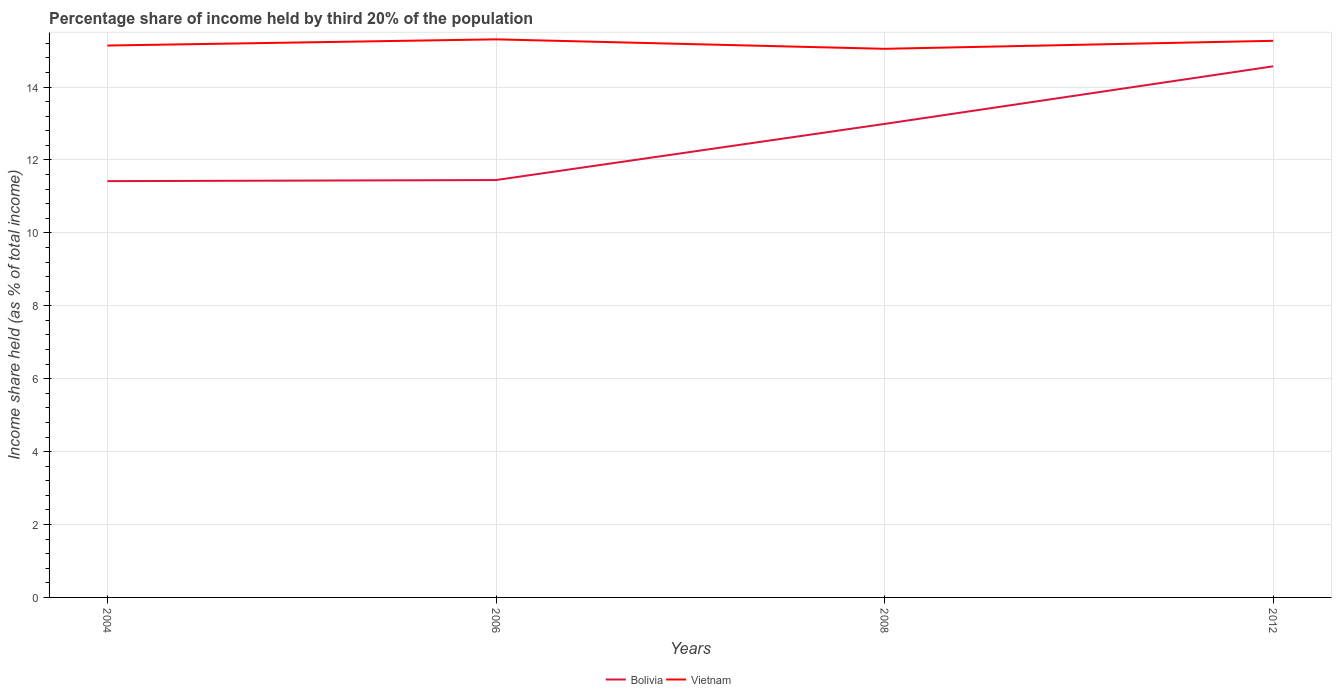Across all years, what is the maximum share of income held by third 20% of the population in Bolivia?
Give a very brief answer. 11.42. In which year was the share of income held by third 20% of the population in Vietnam maximum?
Keep it short and to the point. 2008. What is the total share of income held by third 20% of the population in Bolivia in the graph?
Your response must be concise. -0.03. What is the difference between the highest and the second highest share of income held by third 20% of the population in Vietnam?
Your response must be concise. 0.26. Is the share of income held by third 20% of the population in Vietnam strictly greater than the share of income held by third 20% of the population in Bolivia over the years?
Your answer should be compact. No. How many lines are there?
Offer a terse response. 2. Are the values on the major ticks of Y-axis written in scientific E-notation?
Provide a succinct answer. No. Does the graph contain any zero values?
Keep it short and to the point. No. Does the graph contain grids?
Offer a terse response. Yes. Where does the legend appear in the graph?
Provide a succinct answer. Bottom center. How are the legend labels stacked?
Offer a terse response. Horizontal. What is the title of the graph?
Your answer should be very brief. Percentage share of income held by third 20% of the population. What is the label or title of the X-axis?
Provide a succinct answer. Years. What is the label or title of the Y-axis?
Offer a very short reply. Income share held (as % of total income). What is the Income share held (as % of total income) of Bolivia in 2004?
Provide a succinct answer. 11.42. What is the Income share held (as % of total income) of Vietnam in 2004?
Your answer should be very brief. 15.14. What is the Income share held (as % of total income) in Bolivia in 2006?
Make the answer very short. 11.45. What is the Income share held (as % of total income) of Vietnam in 2006?
Ensure brevity in your answer.  15.31. What is the Income share held (as % of total income) in Bolivia in 2008?
Make the answer very short. 12.99. What is the Income share held (as % of total income) of Vietnam in 2008?
Provide a short and direct response. 15.05. What is the Income share held (as % of total income) of Bolivia in 2012?
Provide a succinct answer. 14.57. What is the Income share held (as % of total income) of Vietnam in 2012?
Provide a short and direct response. 15.27. Across all years, what is the maximum Income share held (as % of total income) in Bolivia?
Provide a succinct answer. 14.57. Across all years, what is the maximum Income share held (as % of total income) in Vietnam?
Make the answer very short. 15.31. Across all years, what is the minimum Income share held (as % of total income) of Bolivia?
Your answer should be compact. 11.42. Across all years, what is the minimum Income share held (as % of total income) of Vietnam?
Ensure brevity in your answer.  15.05. What is the total Income share held (as % of total income) in Bolivia in the graph?
Your response must be concise. 50.43. What is the total Income share held (as % of total income) of Vietnam in the graph?
Your response must be concise. 60.77. What is the difference between the Income share held (as % of total income) of Bolivia in 2004 and that in 2006?
Your answer should be very brief. -0.03. What is the difference between the Income share held (as % of total income) in Vietnam in 2004 and that in 2006?
Make the answer very short. -0.17. What is the difference between the Income share held (as % of total income) in Bolivia in 2004 and that in 2008?
Offer a very short reply. -1.57. What is the difference between the Income share held (as % of total income) of Vietnam in 2004 and that in 2008?
Give a very brief answer. 0.09. What is the difference between the Income share held (as % of total income) of Bolivia in 2004 and that in 2012?
Your answer should be very brief. -3.15. What is the difference between the Income share held (as % of total income) of Vietnam in 2004 and that in 2012?
Provide a succinct answer. -0.13. What is the difference between the Income share held (as % of total income) of Bolivia in 2006 and that in 2008?
Provide a short and direct response. -1.54. What is the difference between the Income share held (as % of total income) of Vietnam in 2006 and that in 2008?
Offer a very short reply. 0.26. What is the difference between the Income share held (as % of total income) of Bolivia in 2006 and that in 2012?
Give a very brief answer. -3.12. What is the difference between the Income share held (as % of total income) in Vietnam in 2006 and that in 2012?
Keep it short and to the point. 0.04. What is the difference between the Income share held (as % of total income) of Bolivia in 2008 and that in 2012?
Your response must be concise. -1.58. What is the difference between the Income share held (as % of total income) of Vietnam in 2008 and that in 2012?
Give a very brief answer. -0.22. What is the difference between the Income share held (as % of total income) in Bolivia in 2004 and the Income share held (as % of total income) in Vietnam in 2006?
Make the answer very short. -3.89. What is the difference between the Income share held (as % of total income) of Bolivia in 2004 and the Income share held (as % of total income) of Vietnam in 2008?
Offer a very short reply. -3.63. What is the difference between the Income share held (as % of total income) in Bolivia in 2004 and the Income share held (as % of total income) in Vietnam in 2012?
Keep it short and to the point. -3.85. What is the difference between the Income share held (as % of total income) of Bolivia in 2006 and the Income share held (as % of total income) of Vietnam in 2008?
Keep it short and to the point. -3.6. What is the difference between the Income share held (as % of total income) in Bolivia in 2006 and the Income share held (as % of total income) in Vietnam in 2012?
Give a very brief answer. -3.82. What is the difference between the Income share held (as % of total income) of Bolivia in 2008 and the Income share held (as % of total income) of Vietnam in 2012?
Offer a very short reply. -2.28. What is the average Income share held (as % of total income) of Bolivia per year?
Offer a terse response. 12.61. What is the average Income share held (as % of total income) of Vietnam per year?
Make the answer very short. 15.19. In the year 2004, what is the difference between the Income share held (as % of total income) of Bolivia and Income share held (as % of total income) of Vietnam?
Your response must be concise. -3.72. In the year 2006, what is the difference between the Income share held (as % of total income) in Bolivia and Income share held (as % of total income) in Vietnam?
Ensure brevity in your answer.  -3.86. In the year 2008, what is the difference between the Income share held (as % of total income) of Bolivia and Income share held (as % of total income) of Vietnam?
Make the answer very short. -2.06. What is the ratio of the Income share held (as % of total income) in Vietnam in 2004 to that in 2006?
Make the answer very short. 0.99. What is the ratio of the Income share held (as % of total income) in Bolivia in 2004 to that in 2008?
Your answer should be very brief. 0.88. What is the ratio of the Income share held (as % of total income) in Vietnam in 2004 to that in 2008?
Your answer should be very brief. 1.01. What is the ratio of the Income share held (as % of total income) of Bolivia in 2004 to that in 2012?
Your answer should be compact. 0.78. What is the ratio of the Income share held (as % of total income) of Bolivia in 2006 to that in 2008?
Provide a short and direct response. 0.88. What is the ratio of the Income share held (as % of total income) in Vietnam in 2006 to that in 2008?
Provide a succinct answer. 1.02. What is the ratio of the Income share held (as % of total income) of Bolivia in 2006 to that in 2012?
Provide a succinct answer. 0.79. What is the ratio of the Income share held (as % of total income) in Bolivia in 2008 to that in 2012?
Ensure brevity in your answer.  0.89. What is the ratio of the Income share held (as % of total income) of Vietnam in 2008 to that in 2012?
Offer a very short reply. 0.99. What is the difference between the highest and the second highest Income share held (as % of total income) of Bolivia?
Keep it short and to the point. 1.58. What is the difference between the highest and the second highest Income share held (as % of total income) in Vietnam?
Keep it short and to the point. 0.04. What is the difference between the highest and the lowest Income share held (as % of total income) of Bolivia?
Provide a short and direct response. 3.15. What is the difference between the highest and the lowest Income share held (as % of total income) of Vietnam?
Your answer should be compact. 0.26. 